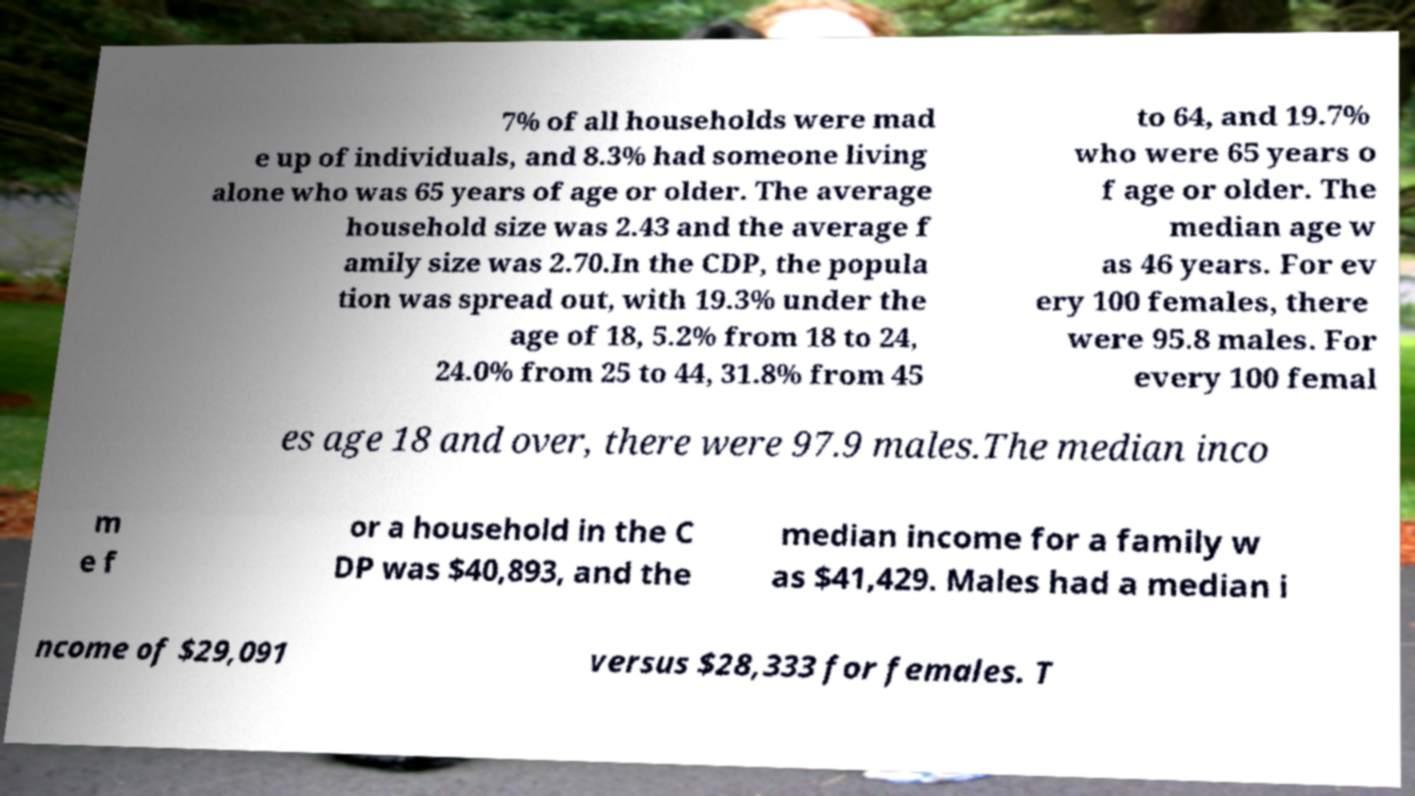Please read and relay the text visible in this image. What does it say? 7% of all households were mad e up of individuals, and 8.3% had someone living alone who was 65 years of age or older. The average household size was 2.43 and the average f amily size was 2.70.In the CDP, the popula tion was spread out, with 19.3% under the age of 18, 5.2% from 18 to 24, 24.0% from 25 to 44, 31.8% from 45 to 64, and 19.7% who were 65 years o f age or older. The median age w as 46 years. For ev ery 100 females, there were 95.8 males. For every 100 femal es age 18 and over, there were 97.9 males.The median inco m e f or a household in the C DP was $40,893, and the median income for a family w as $41,429. Males had a median i ncome of $29,091 versus $28,333 for females. T 